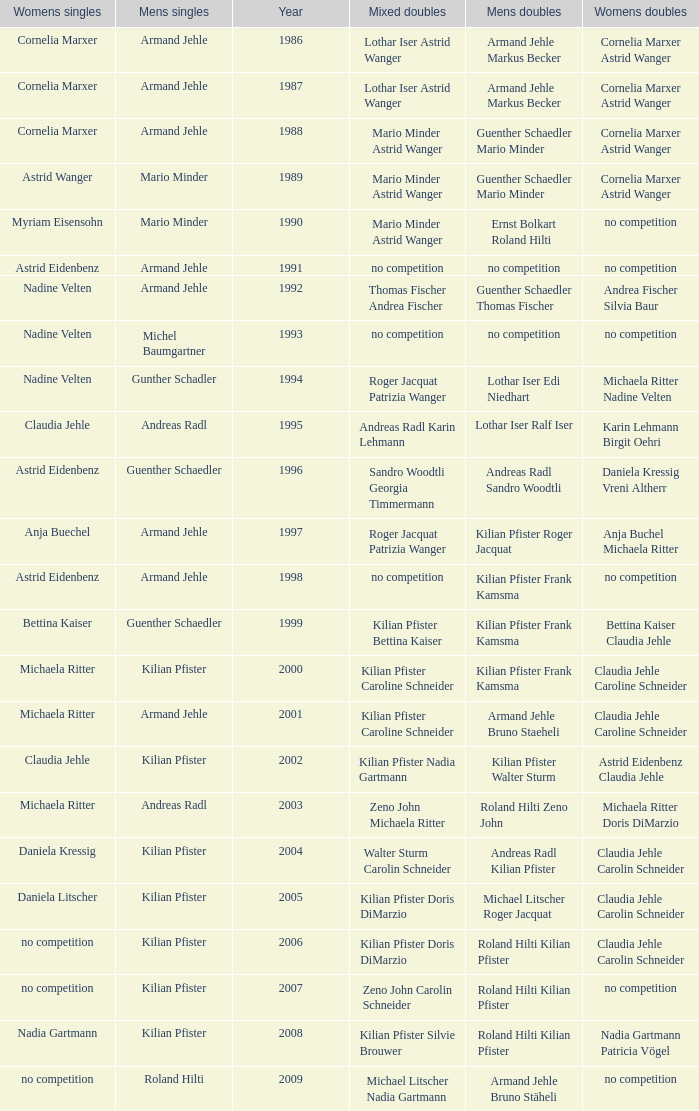What is the most current year where the women's doubles champions are astrid eidenbenz claudia jehle 2002.0. 